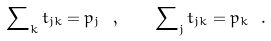Convert formula to latex. <formula><loc_0><loc_0><loc_500><loc_500>\sum \nolimits _ { k } t _ { j k } = p _ { j } \ , \quad \sum \nolimits _ { j } t _ { j k } = p _ { k } \ .</formula> 